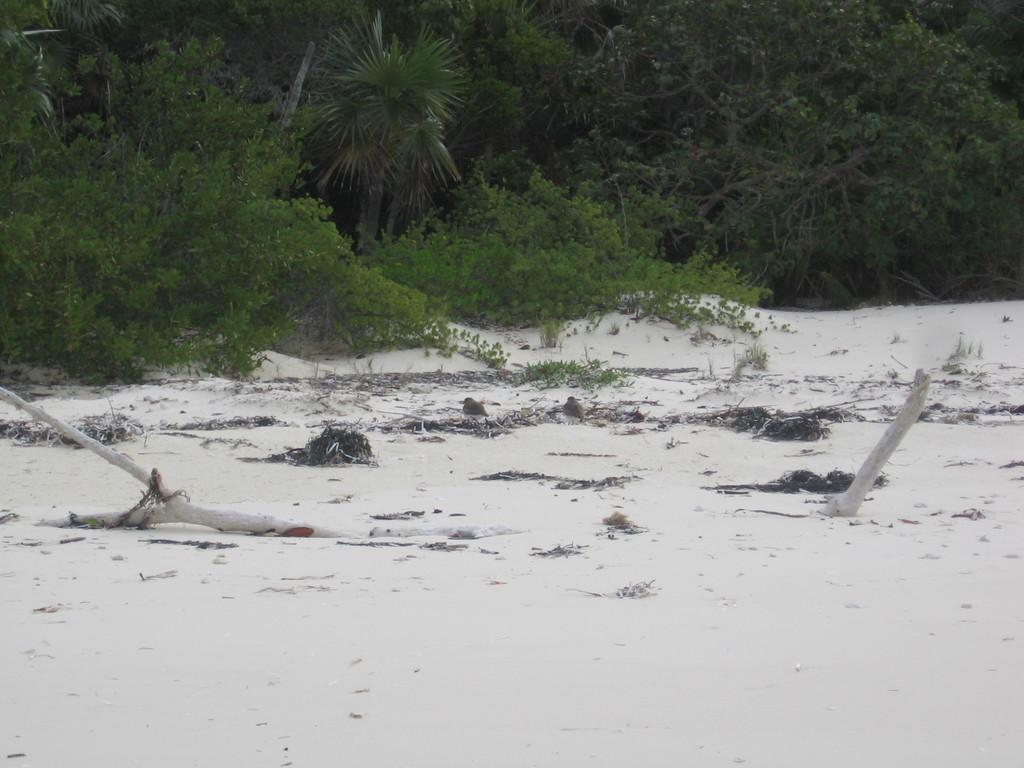What is at the bottom of the image? There is sand at the bottom of the image. What can be seen in the middle of the image? There are green color trees in the middle of the image. Where is the quill located in the image? There is no quill present in the image. What type of bushes can be seen in the image? There is no mention of bushes in the provided facts, and only trees are mentioned. 